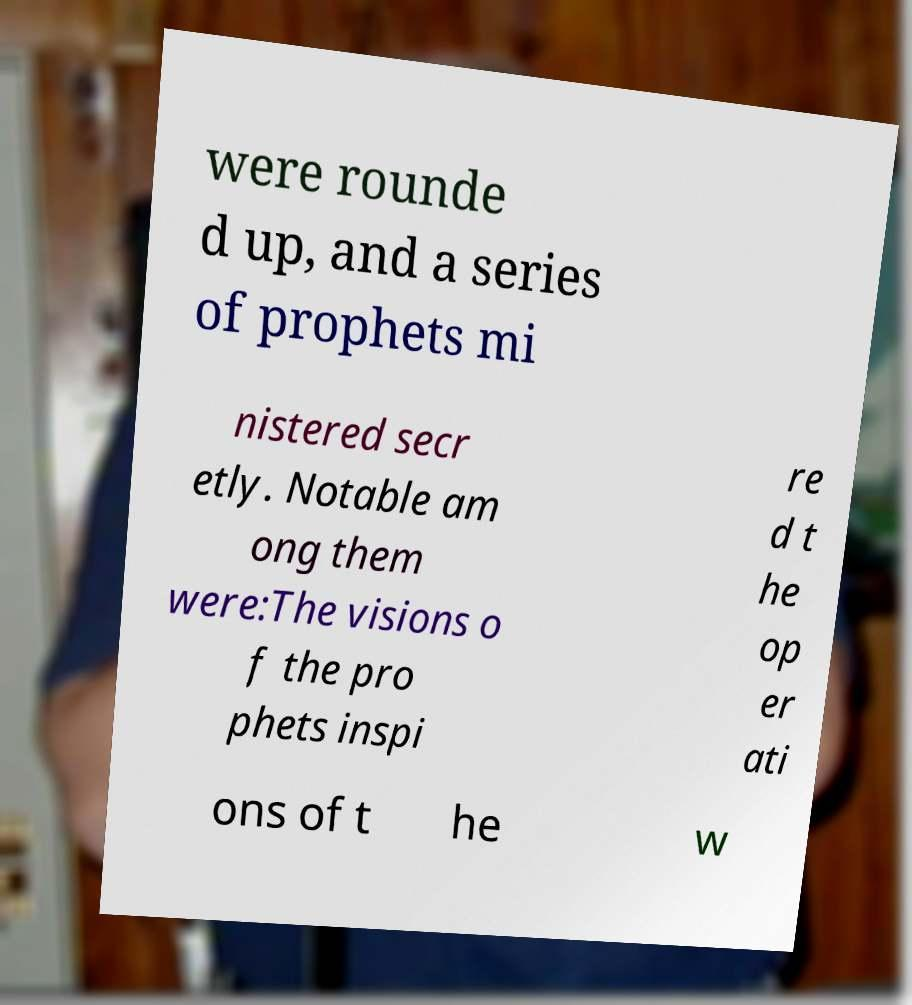Could you extract and type out the text from this image? were rounde d up, and a series of prophets mi nistered secr etly. Notable am ong them were:The visions o f the pro phets inspi re d t he op er ati ons of t he w 